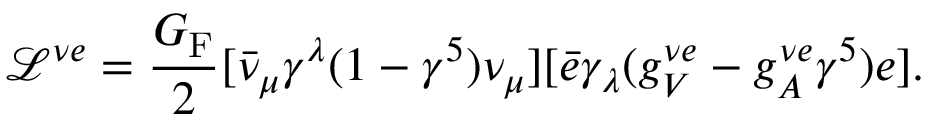Convert formula to latex. <formula><loc_0><loc_0><loc_500><loc_500>\mathcal { L } ^ { \nu e } = \frac { G _ { F } } { 2 } [ \bar { \nu } _ { \mu } \gamma ^ { \lambda } ( 1 - \gamma ^ { 5 } ) \nu _ { \mu } ] [ \bar { e } \gamma _ { \lambda } ( g _ { V } ^ { \nu e } - g _ { A } ^ { \nu e } \gamma ^ { 5 } ) e ] .</formula> 